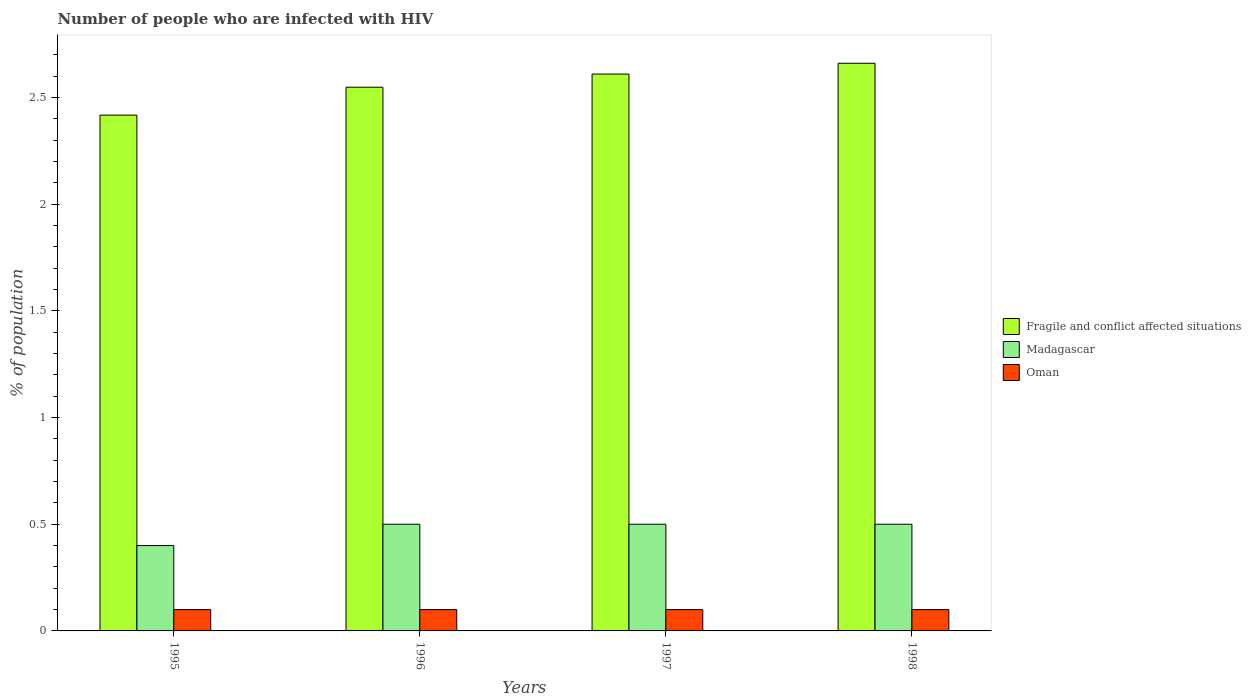How many groups of bars are there?
Your answer should be very brief. 4. How many bars are there on the 3rd tick from the left?
Provide a succinct answer. 3. How many bars are there on the 4th tick from the right?
Make the answer very short. 3. In how many cases, is the number of bars for a given year not equal to the number of legend labels?
Make the answer very short. 0. What is the percentage of HIV infected population in in Oman in 1996?
Your answer should be very brief. 0.1. Across all years, what is the maximum percentage of HIV infected population in in Fragile and conflict affected situations?
Keep it short and to the point. 2.66. In which year was the percentage of HIV infected population in in Oman maximum?
Your response must be concise. 1995. What is the total percentage of HIV infected population in in Oman in the graph?
Ensure brevity in your answer.  0.4. What is the difference between the percentage of HIV infected population in in Madagascar in 1995 and that in 1998?
Ensure brevity in your answer.  -0.1. What is the difference between the percentage of HIV infected population in in Oman in 1998 and the percentage of HIV infected population in in Fragile and conflict affected situations in 1996?
Make the answer very short. -2.45. What is the average percentage of HIV infected population in in Madagascar per year?
Your response must be concise. 0.47. In the year 1997, what is the difference between the percentage of HIV infected population in in Oman and percentage of HIV infected population in in Fragile and conflict affected situations?
Make the answer very short. -2.51. What is the ratio of the percentage of HIV infected population in in Fragile and conflict affected situations in 1995 to that in 1996?
Keep it short and to the point. 0.95. What is the difference between the highest and the second highest percentage of HIV infected population in in Oman?
Offer a very short reply. 0. What is the difference between the highest and the lowest percentage of HIV infected population in in Madagascar?
Make the answer very short. 0.1. Is the sum of the percentage of HIV infected population in in Fragile and conflict affected situations in 1995 and 1996 greater than the maximum percentage of HIV infected population in in Madagascar across all years?
Make the answer very short. Yes. What does the 1st bar from the left in 1997 represents?
Provide a succinct answer. Fragile and conflict affected situations. What does the 3rd bar from the right in 1996 represents?
Your answer should be compact. Fragile and conflict affected situations. How many bars are there?
Offer a terse response. 12. How many years are there in the graph?
Offer a very short reply. 4. What is the difference between two consecutive major ticks on the Y-axis?
Your answer should be compact. 0.5. Does the graph contain any zero values?
Offer a very short reply. No. Does the graph contain grids?
Make the answer very short. No. Where does the legend appear in the graph?
Give a very brief answer. Center right. How are the legend labels stacked?
Ensure brevity in your answer.  Vertical. What is the title of the graph?
Offer a very short reply. Number of people who are infected with HIV. What is the label or title of the X-axis?
Offer a terse response. Years. What is the label or title of the Y-axis?
Offer a terse response. % of population. What is the % of population of Fragile and conflict affected situations in 1995?
Offer a very short reply. 2.42. What is the % of population in Madagascar in 1995?
Your answer should be very brief. 0.4. What is the % of population in Fragile and conflict affected situations in 1996?
Make the answer very short. 2.55. What is the % of population in Fragile and conflict affected situations in 1997?
Offer a very short reply. 2.61. What is the % of population in Madagascar in 1997?
Your response must be concise. 0.5. What is the % of population of Oman in 1997?
Provide a short and direct response. 0.1. What is the % of population of Fragile and conflict affected situations in 1998?
Keep it short and to the point. 2.66. What is the % of population in Madagascar in 1998?
Ensure brevity in your answer.  0.5. Across all years, what is the maximum % of population in Fragile and conflict affected situations?
Offer a terse response. 2.66. Across all years, what is the maximum % of population of Madagascar?
Keep it short and to the point. 0.5. Across all years, what is the minimum % of population of Fragile and conflict affected situations?
Give a very brief answer. 2.42. Across all years, what is the minimum % of population in Oman?
Ensure brevity in your answer.  0.1. What is the total % of population in Fragile and conflict affected situations in the graph?
Provide a short and direct response. 10.23. What is the difference between the % of population of Fragile and conflict affected situations in 1995 and that in 1996?
Make the answer very short. -0.13. What is the difference between the % of population of Madagascar in 1995 and that in 1996?
Offer a terse response. -0.1. What is the difference between the % of population in Oman in 1995 and that in 1996?
Your answer should be compact. 0. What is the difference between the % of population of Fragile and conflict affected situations in 1995 and that in 1997?
Ensure brevity in your answer.  -0.19. What is the difference between the % of population of Madagascar in 1995 and that in 1997?
Give a very brief answer. -0.1. What is the difference between the % of population of Fragile and conflict affected situations in 1995 and that in 1998?
Provide a succinct answer. -0.24. What is the difference between the % of population of Madagascar in 1995 and that in 1998?
Offer a terse response. -0.1. What is the difference between the % of population in Fragile and conflict affected situations in 1996 and that in 1997?
Keep it short and to the point. -0.06. What is the difference between the % of population of Madagascar in 1996 and that in 1997?
Your answer should be very brief. 0. What is the difference between the % of population in Fragile and conflict affected situations in 1996 and that in 1998?
Keep it short and to the point. -0.11. What is the difference between the % of population in Madagascar in 1996 and that in 1998?
Keep it short and to the point. 0. What is the difference between the % of population in Oman in 1996 and that in 1998?
Ensure brevity in your answer.  0. What is the difference between the % of population in Fragile and conflict affected situations in 1997 and that in 1998?
Make the answer very short. -0.05. What is the difference between the % of population of Madagascar in 1997 and that in 1998?
Keep it short and to the point. 0. What is the difference between the % of population of Oman in 1997 and that in 1998?
Your answer should be compact. 0. What is the difference between the % of population in Fragile and conflict affected situations in 1995 and the % of population in Madagascar in 1996?
Keep it short and to the point. 1.92. What is the difference between the % of population of Fragile and conflict affected situations in 1995 and the % of population of Oman in 1996?
Make the answer very short. 2.32. What is the difference between the % of population in Fragile and conflict affected situations in 1995 and the % of population in Madagascar in 1997?
Ensure brevity in your answer.  1.92. What is the difference between the % of population of Fragile and conflict affected situations in 1995 and the % of population of Oman in 1997?
Your answer should be compact. 2.32. What is the difference between the % of population in Fragile and conflict affected situations in 1995 and the % of population in Madagascar in 1998?
Offer a terse response. 1.92. What is the difference between the % of population in Fragile and conflict affected situations in 1995 and the % of population in Oman in 1998?
Give a very brief answer. 2.32. What is the difference between the % of population of Fragile and conflict affected situations in 1996 and the % of population of Madagascar in 1997?
Offer a terse response. 2.05. What is the difference between the % of population in Fragile and conflict affected situations in 1996 and the % of population in Oman in 1997?
Ensure brevity in your answer.  2.45. What is the difference between the % of population of Madagascar in 1996 and the % of population of Oman in 1997?
Keep it short and to the point. 0.4. What is the difference between the % of population in Fragile and conflict affected situations in 1996 and the % of population in Madagascar in 1998?
Offer a terse response. 2.05. What is the difference between the % of population in Fragile and conflict affected situations in 1996 and the % of population in Oman in 1998?
Offer a very short reply. 2.45. What is the difference between the % of population in Madagascar in 1996 and the % of population in Oman in 1998?
Offer a very short reply. 0.4. What is the difference between the % of population of Fragile and conflict affected situations in 1997 and the % of population of Madagascar in 1998?
Your response must be concise. 2.11. What is the difference between the % of population in Fragile and conflict affected situations in 1997 and the % of population in Oman in 1998?
Offer a terse response. 2.51. What is the difference between the % of population of Madagascar in 1997 and the % of population of Oman in 1998?
Ensure brevity in your answer.  0.4. What is the average % of population of Fragile and conflict affected situations per year?
Make the answer very short. 2.56. What is the average % of population in Madagascar per year?
Your response must be concise. 0.47. What is the average % of population of Oman per year?
Your answer should be very brief. 0.1. In the year 1995, what is the difference between the % of population of Fragile and conflict affected situations and % of population of Madagascar?
Offer a terse response. 2.02. In the year 1995, what is the difference between the % of population in Fragile and conflict affected situations and % of population in Oman?
Your answer should be very brief. 2.32. In the year 1996, what is the difference between the % of population of Fragile and conflict affected situations and % of population of Madagascar?
Give a very brief answer. 2.05. In the year 1996, what is the difference between the % of population in Fragile and conflict affected situations and % of population in Oman?
Offer a very short reply. 2.45. In the year 1996, what is the difference between the % of population of Madagascar and % of population of Oman?
Provide a succinct answer. 0.4. In the year 1997, what is the difference between the % of population in Fragile and conflict affected situations and % of population in Madagascar?
Make the answer very short. 2.11. In the year 1997, what is the difference between the % of population of Fragile and conflict affected situations and % of population of Oman?
Your answer should be compact. 2.51. In the year 1997, what is the difference between the % of population of Madagascar and % of population of Oman?
Your answer should be compact. 0.4. In the year 1998, what is the difference between the % of population in Fragile and conflict affected situations and % of population in Madagascar?
Offer a very short reply. 2.16. In the year 1998, what is the difference between the % of population of Fragile and conflict affected situations and % of population of Oman?
Ensure brevity in your answer.  2.56. What is the ratio of the % of population of Fragile and conflict affected situations in 1995 to that in 1996?
Offer a very short reply. 0.95. What is the ratio of the % of population in Oman in 1995 to that in 1996?
Offer a very short reply. 1. What is the ratio of the % of population of Fragile and conflict affected situations in 1995 to that in 1997?
Your answer should be very brief. 0.93. What is the ratio of the % of population of Oman in 1995 to that in 1997?
Provide a short and direct response. 1. What is the ratio of the % of population in Fragile and conflict affected situations in 1995 to that in 1998?
Provide a succinct answer. 0.91. What is the ratio of the % of population of Fragile and conflict affected situations in 1996 to that in 1997?
Offer a very short reply. 0.98. What is the ratio of the % of population of Madagascar in 1996 to that in 1997?
Make the answer very short. 1. What is the ratio of the % of population of Fragile and conflict affected situations in 1996 to that in 1998?
Give a very brief answer. 0.96. What is the ratio of the % of population of Fragile and conflict affected situations in 1997 to that in 1998?
Make the answer very short. 0.98. What is the difference between the highest and the second highest % of population of Fragile and conflict affected situations?
Your response must be concise. 0.05. What is the difference between the highest and the second highest % of population in Madagascar?
Offer a very short reply. 0. What is the difference between the highest and the second highest % of population in Oman?
Provide a short and direct response. 0. What is the difference between the highest and the lowest % of population in Fragile and conflict affected situations?
Provide a short and direct response. 0.24. What is the difference between the highest and the lowest % of population in Oman?
Ensure brevity in your answer.  0. 